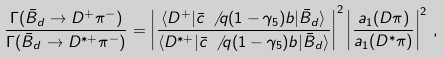<formula> <loc_0><loc_0><loc_500><loc_500>\frac { \Gamma ( \bar { B } _ { d } \to D ^ { + } \pi ^ { - } ) } { \Gamma ( \bar { B } _ { d } \to D ^ { * + } \pi ^ { - } ) } = \left | \frac { \langle D ^ { + } | \bar { c } \, \not \, q ( 1 - \gamma _ { 5 } ) b | \bar { B } _ { d } \rangle } { \langle D ^ { * + } | \bar { c } \, \not \, q ( 1 - \gamma _ { 5 } ) b | \bar { B } _ { d } \rangle } \right | ^ { 2 } \left | \frac { a _ { 1 } ( D \pi ) } { a _ { 1 } ( D ^ { * } \pi ) } \right | ^ { 2 } \, ,</formula> 